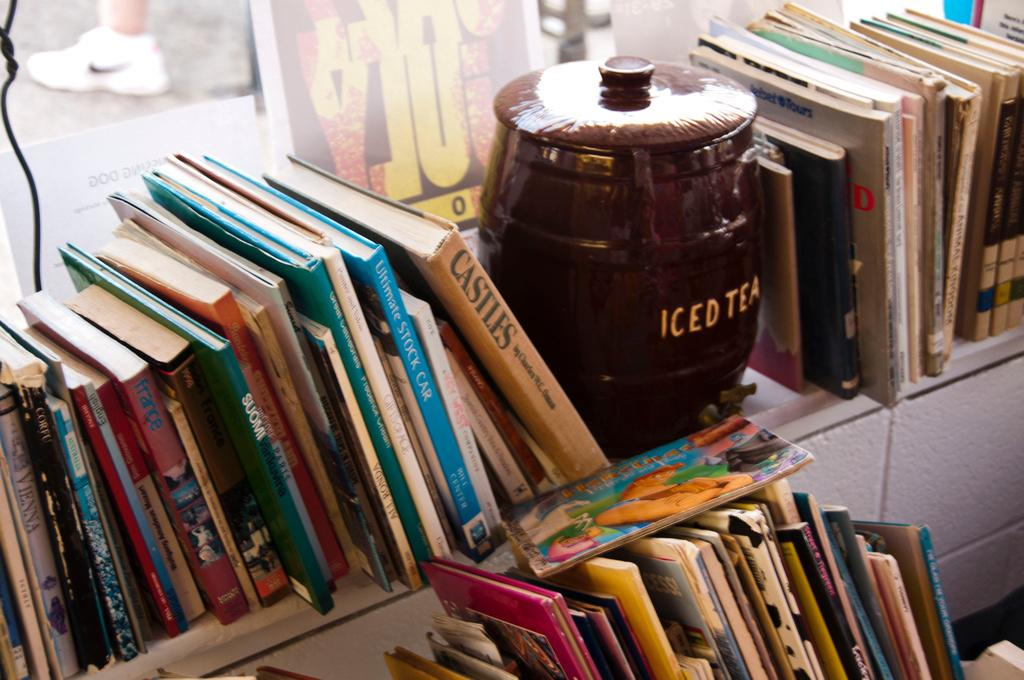What type of furniture is present in the image? There is a bookshelf in the image. What is stored on the bookshelf? There are books on the bookshelf. What other object can be seen in the image? There is a jar in the image. What type of bulb is used to light up the bookshelf in the image? There is no information about lighting in the image, and no bulb is mentioned or visible. 